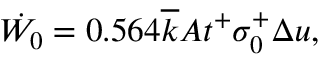Convert formula to latex. <formula><loc_0><loc_0><loc_500><loc_500>\dot { W _ { 0 } } = 0 . 5 6 4 \overline { k } A t ^ { + } \sigma _ { 0 } ^ { + } \Delta u ,</formula> 